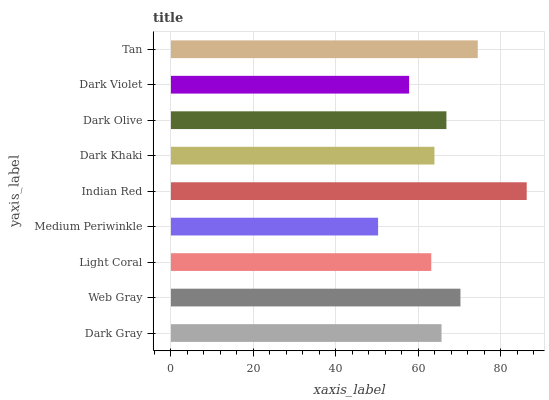Is Medium Periwinkle the minimum?
Answer yes or no. Yes. Is Indian Red the maximum?
Answer yes or no. Yes. Is Web Gray the minimum?
Answer yes or no. No. Is Web Gray the maximum?
Answer yes or no. No. Is Web Gray greater than Dark Gray?
Answer yes or no. Yes. Is Dark Gray less than Web Gray?
Answer yes or no. Yes. Is Dark Gray greater than Web Gray?
Answer yes or no. No. Is Web Gray less than Dark Gray?
Answer yes or no. No. Is Dark Gray the high median?
Answer yes or no. Yes. Is Dark Gray the low median?
Answer yes or no. Yes. Is Web Gray the high median?
Answer yes or no. No. Is Dark Violet the low median?
Answer yes or no. No. 